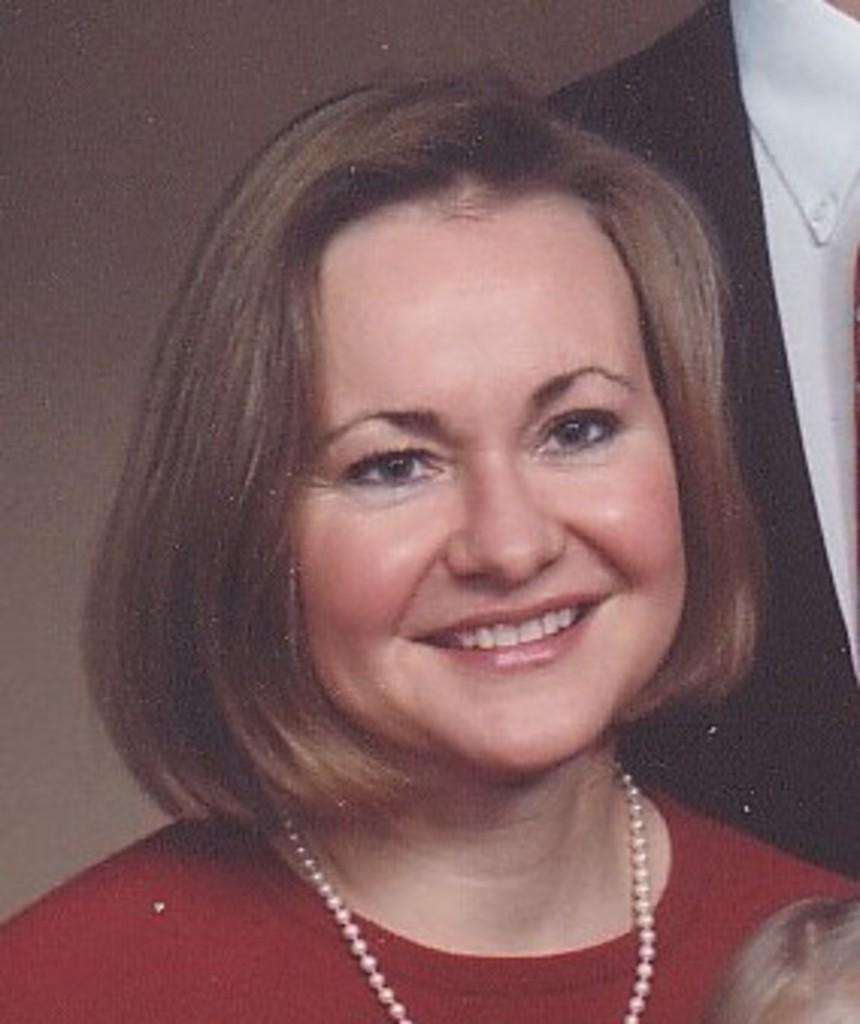In one or two sentences, can you explain what this image depicts? In this image I can see a woman. 